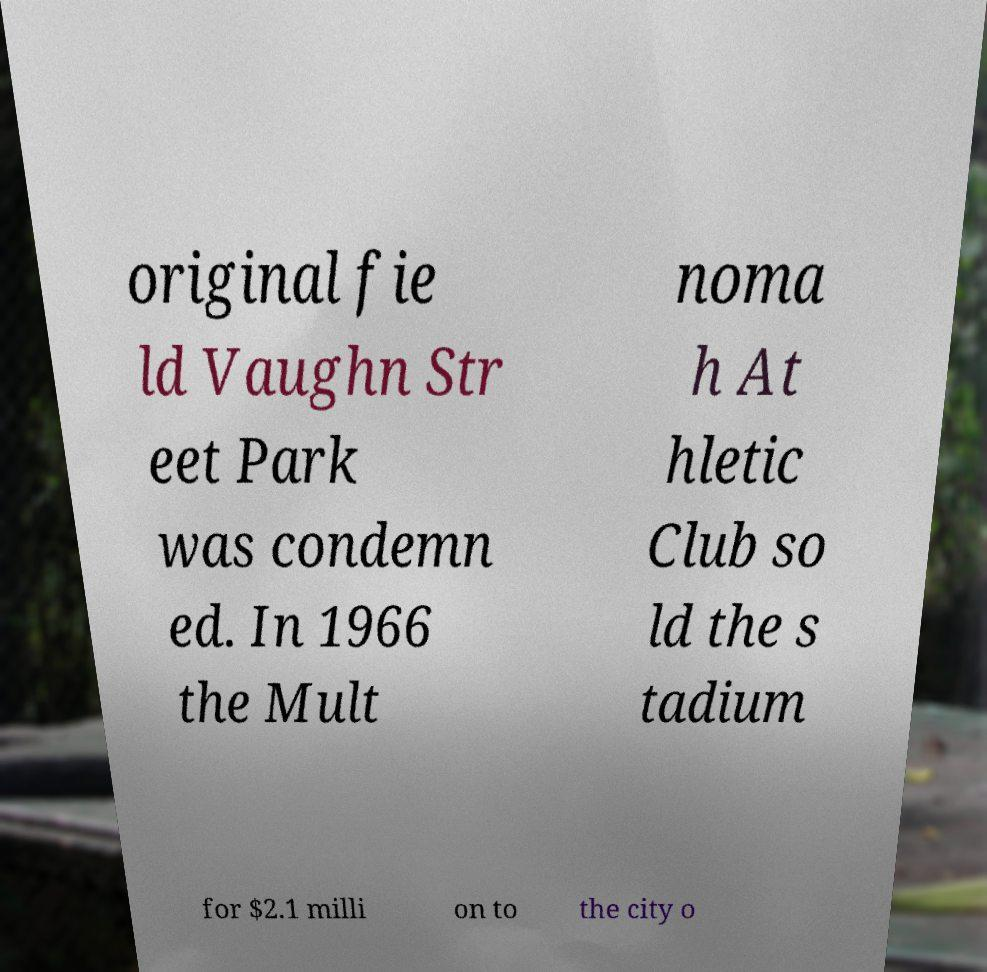What messages or text are displayed in this image? I need them in a readable, typed format. original fie ld Vaughn Str eet Park was condemn ed. In 1966 the Mult noma h At hletic Club so ld the s tadium for $2.1 milli on to the city o 